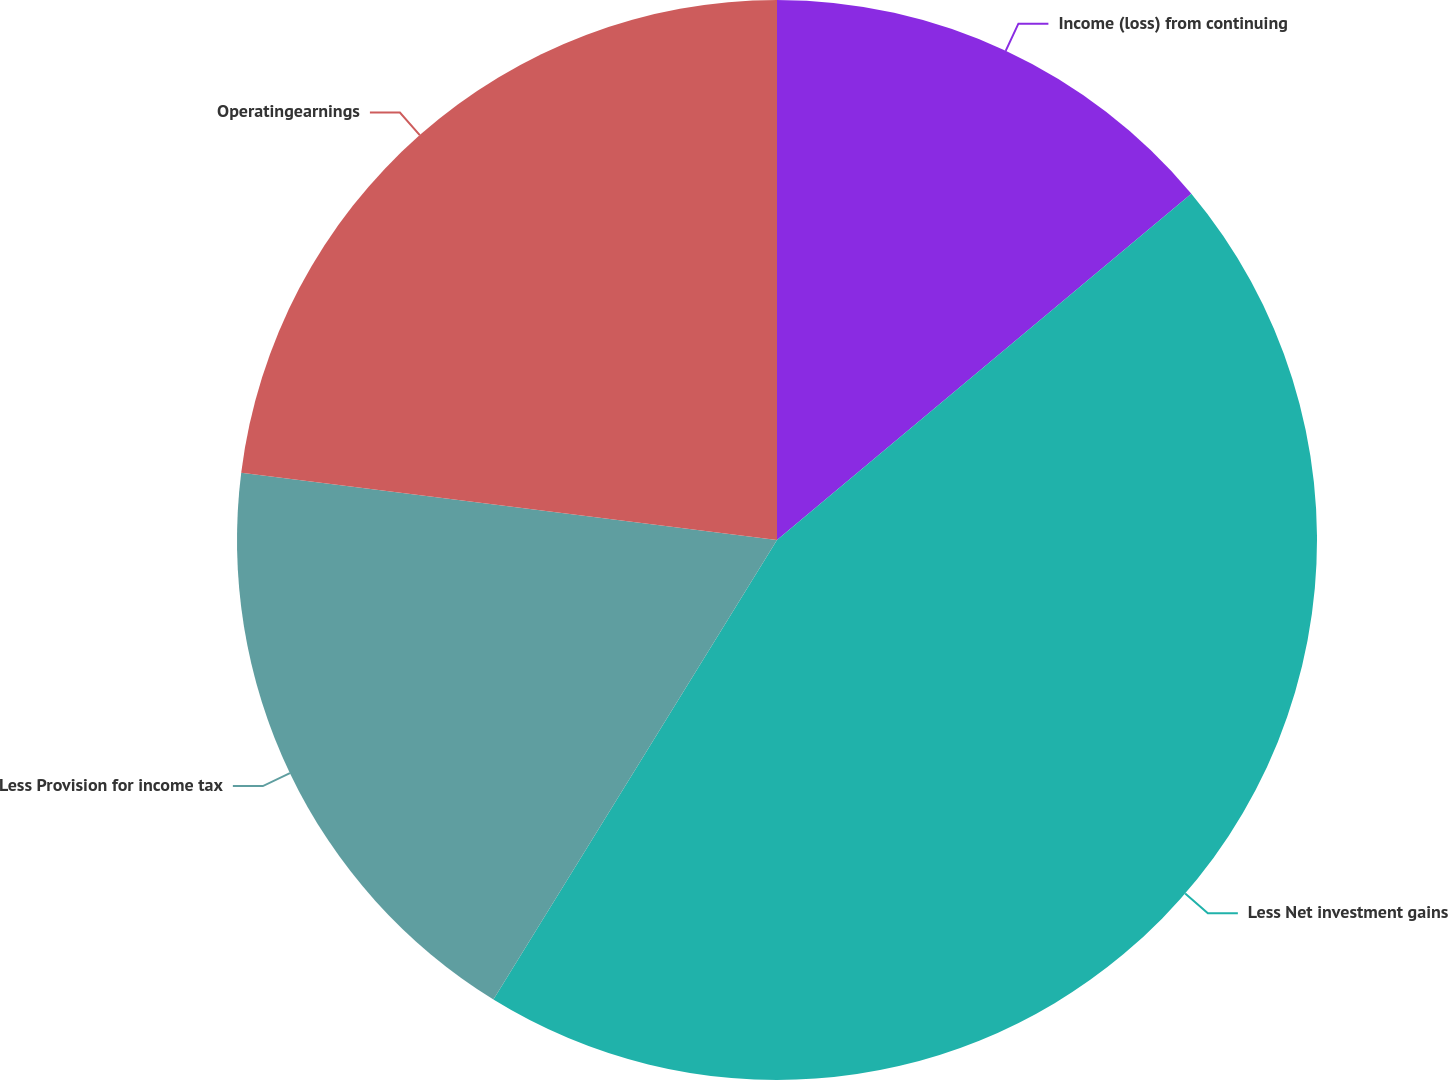Convert chart to OTSL. <chart><loc_0><loc_0><loc_500><loc_500><pie_chart><fcel>Income (loss) from continuing<fcel>Less Net investment gains<fcel>Less Provision for income tax<fcel>Operatingearnings<nl><fcel>13.92%<fcel>44.88%<fcel>18.19%<fcel>23.01%<nl></chart> 